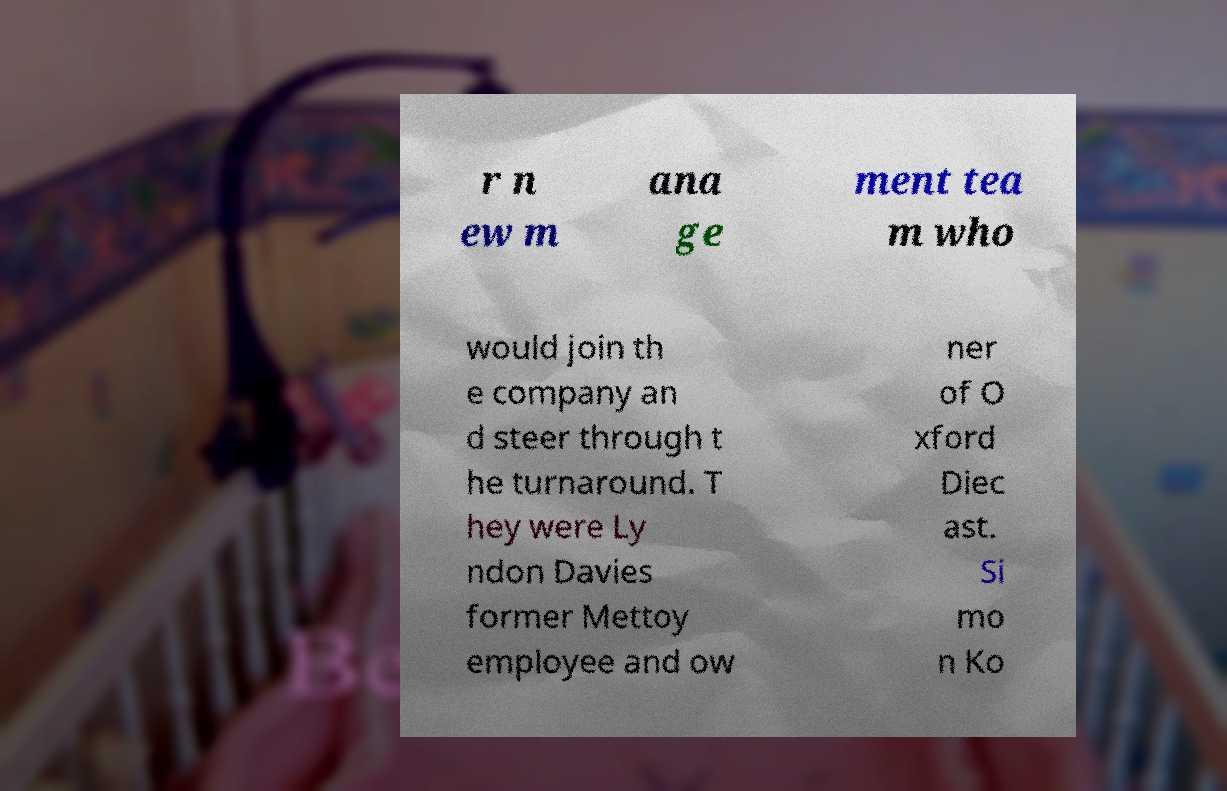What messages or text are displayed in this image? I need them in a readable, typed format. r n ew m ana ge ment tea m who would join th e company an d steer through t he turnaround. T hey were Ly ndon Davies former Mettoy employee and ow ner of O xford Diec ast. Si mo n Ko 